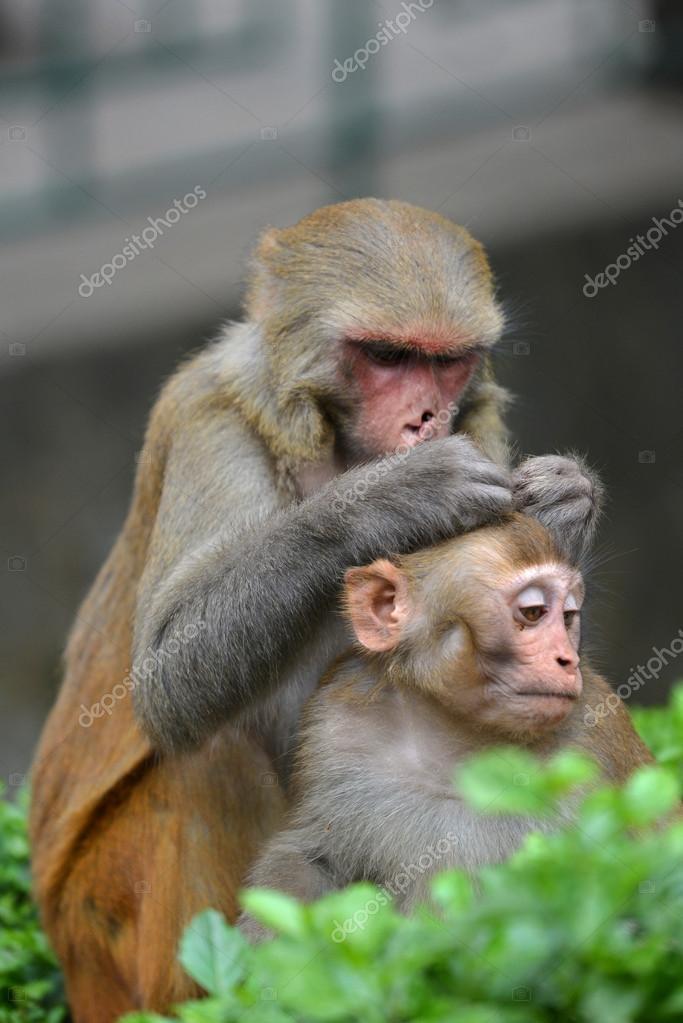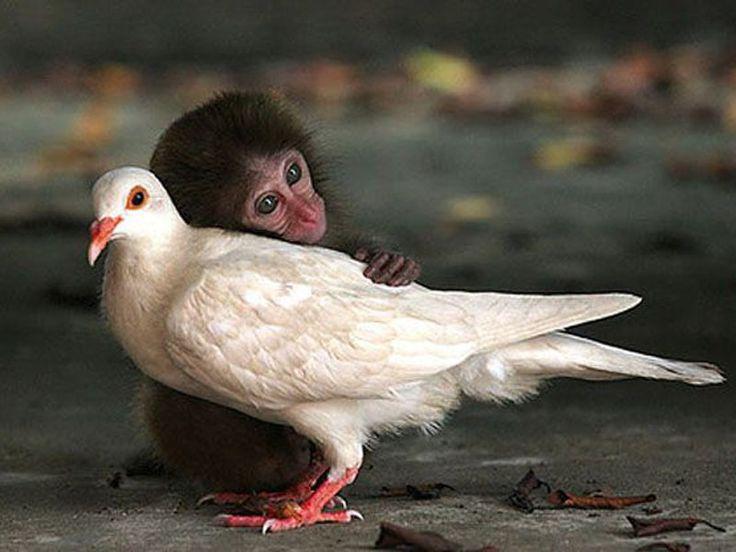The first image is the image on the left, the second image is the image on the right. Given the left and right images, does the statement "There is at least two primates in the left image." hold true? Answer yes or no. Yes. 